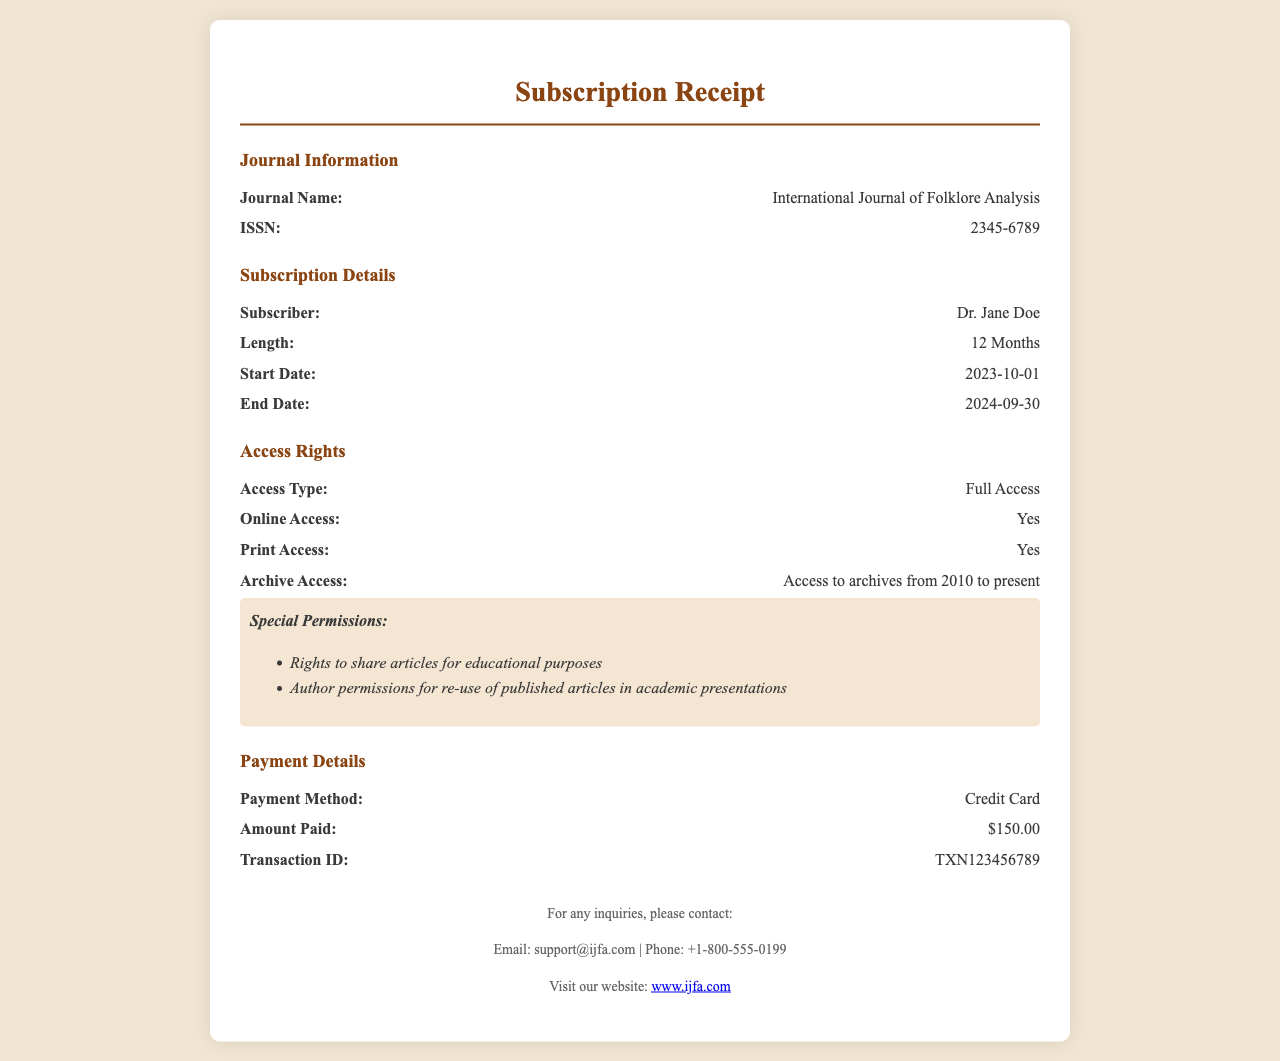What is the subscriber's name? The subscriber's name is mentioned in the subscription details section of the document, which is Dr. Jane Doe.
Answer: Dr. Jane Doe How long is the subscription? The subscription length is specified as 12 months in the subscription details section.
Answer: 12 Months What is the end date of the subscription? The end date can be found in the subscription details section, which states that the subscription ends on September 30, 2024.
Answer: 2024-09-30 What payment method was used? The payment method is listed in the payment details section and states that a Credit Card was used.
Answer: Credit Card What is the amount paid for the subscription? The amount paid is found in the payment details section, which indicates that $150.00 was the payment amount.
Answer: $150.00 What type of access is provided? The access type is mentioned in the access rights section and is noted as Full Access.
Answer: Full Access Does the subscription include print access? The access rights section states whether print access is included, which confirms that the answer is Yes.
Answer: Yes What rights are granted for sharing articles? The special permissions section outlines rights related to educational purposes, specifically mentioning rights to share articles.
Answer: Rights to share articles for educational purposes For which years is archive access available? Archive access availability is detailed in the access rights section, specifically stating access to archives from 2010 to present.
Answer: 2010 to present 